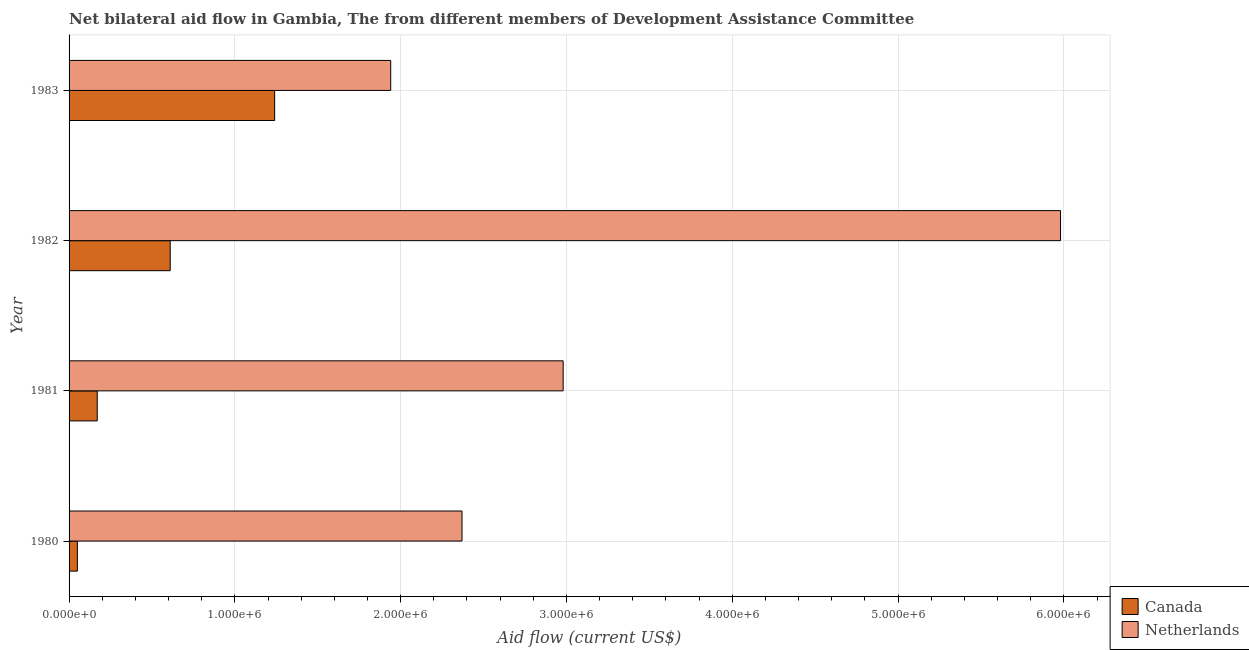How many groups of bars are there?
Your answer should be very brief. 4. Are the number of bars per tick equal to the number of legend labels?
Your answer should be very brief. Yes. Are the number of bars on each tick of the Y-axis equal?
Offer a terse response. Yes. How many bars are there on the 3rd tick from the bottom?
Offer a very short reply. 2. In how many cases, is the number of bars for a given year not equal to the number of legend labels?
Your response must be concise. 0. What is the amount of aid given by canada in 1981?
Your response must be concise. 1.70e+05. Across all years, what is the maximum amount of aid given by netherlands?
Provide a succinct answer. 5.98e+06. Across all years, what is the minimum amount of aid given by netherlands?
Give a very brief answer. 1.94e+06. In which year was the amount of aid given by netherlands maximum?
Your response must be concise. 1982. What is the total amount of aid given by netherlands in the graph?
Offer a terse response. 1.33e+07. What is the difference between the amount of aid given by netherlands in 1981 and that in 1982?
Provide a succinct answer. -3.00e+06. What is the difference between the amount of aid given by canada in 1983 and the amount of aid given by netherlands in 1980?
Provide a succinct answer. -1.13e+06. What is the average amount of aid given by netherlands per year?
Keep it short and to the point. 3.32e+06. In the year 1983, what is the difference between the amount of aid given by netherlands and amount of aid given by canada?
Make the answer very short. 7.00e+05. What is the ratio of the amount of aid given by netherlands in 1980 to that in 1983?
Offer a very short reply. 1.22. Is the amount of aid given by netherlands in 1980 less than that in 1982?
Your answer should be very brief. Yes. Is the difference between the amount of aid given by canada in 1982 and 1983 greater than the difference between the amount of aid given by netherlands in 1982 and 1983?
Make the answer very short. No. What is the difference between the highest and the second highest amount of aid given by netherlands?
Your answer should be compact. 3.00e+06. What is the difference between the highest and the lowest amount of aid given by netherlands?
Your answer should be very brief. 4.04e+06. How many years are there in the graph?
Make the answer very short. 4. What is the difference between two consecutive major ticks on the X-axis?
Ensure brevity in your answer.  1.00e+06. How many legend labels are there?
Offer a very short reply. 2. How are the legend labels stacked?
Provide a short and direct response. Vertical. What is the title of the graph?
Provide a short and direct response. Net bilateral aid flow in Gambia, The from different members of Development Assistance Committee. Does "State government" appear as one of the legend labels in the graph?
Give a very brief answer. No. What is the label or title of the X-axis?
Your response must be concise. Aid flow (current US$). What is the Aid flow (current US$) of Netherlands in 1980?
Your response must be concise. 2.37e+06. What is the Aid flow (current US$) in Netherlands in 1981?
Your answer should be very brief. 2.98e+06. What is the Aid flow (current US$) of Canada in 1982?
Offer a very short reply. 6.10e+05. What is the Aid flow (current US$) in Netherlands in 1982?
Your answer should be very brief. 5.98e+06. What is the Aid flow (current US$) of Canada in 1983?
Offer a terse response. 1.24e+06. What is the Aid flow (current US$) in Netherlands in 1983?
Your answer should be compact. 1.94e+06. Across all years, what is the maximum Aid flow (current US$) of Canada?
Provide a short and direct response. 1.24e+06. Across all years, what is the maximum Aid flow (current US$) in Netherlands?
Give a very brief answer. 5.98e+06. Across all years, what is the minimum Aid flow (current US$) in Canada?
Keep it short and to the point. 5.00e+04. Across all years, what is the minimum Aid flow (current US$) in Netherlands?
Offer a terse response. 1.94e+06. What is the total Aid flow (current US$) of Canada in the graph?
Offer a very short reply. 2.07e+06. What is the total Aid flow (current US$) of Netherlands in the graph?
Ensure brevity in your answer.  1.33e+07. What is the difference between the Aid flow (current US$) in Netherlands in 1980 and that in 1981?
Provide a short and direct response. -6.10e+05. What is the difference between the Aid flow (current US$) in Canada in 1980 and that in 1982?
Give a very brief answer. -5.60e+05. What is the difference between the Aid flow (current US$) of Netherlands in 1980 and that in 1982?
Offer a terse response. -3.61e+06. What is the difference between the Aid flow (current US$) of Canada in 1980 and that in 1983?
Give a very brief answer. -1.19e+06. What is the difference between the Aid flow (current US$) of Netherlands in 1980 and that in 1983?
Offer a terse response. 4.30e+05. What is the difference between the Aid flow (current US$) in Canada in 1981 and that in 1982?
Your answer should be compact. -4.40e+05. What is the difference between the Aid flow (current US$) in Canada in 1981 and that in 1983?
Provide a succinct answer. -1.07e+06. What is the difference between the Aid flow (current US$) in Netherlands in 1981 and that in 1983?
Ensure brevity in your answer.  1.04e+06. What is the difference between the Aid flow (current US$) in Canada in 1982 and that in 1983?
Your answer should be compact. -6.30e+05. What is the difference between the Aid flow (current US$) in Netherlands in 1982 and that in 1983?
Offer a very short reply. 4.04e+06. What is the difference between the Aid flow (current US$) of Canada in 1980 and the Aid flow (current US$) of Netherlands in 1981?
Ensure brevity in your answer.  -2.93e+06. What is the difference between the Aid flow (current US$) of Canada in 1980 and the Aid flow (current US$) of Netherlands in 1982?
Provide a succinct answer. -5.93e+06. What is the difference between the Aid flow (current US$) in Canada in 1980 and the Aid flow (current US$) in Netherlands in 1983?
Provide a succinct answer. -1.89e+06. What is the difference between the Aid flow (current US$) in Canada in 1981 and the Aid flow (current US$) in Netherlands in 1982?
Your answer should be very brief. -5.81e+06. What is the difference between the Aid flow (current US$) of Canada in 1981 and the Aid flow (current US$) of Netherlands in 1983?
Ensure brevity in your answer.  -1.77e+06. What is the difference between the Aid flow (current US$) in Canada in 1982 and the Aid flow (current US$) in Netherlands in 1983?
Make the answer very short. -1.33e+06. What is the average Aid flow (current US$) of Canada per year?
Your answer should be very brief. 5.18e+05. What is the average Aid flow (current US$) of Netherlands per year?
Keep it short and to the point. 3.32e+06. In the year 1980, what is the difference between the Aid flow (current US$) of Canada and Aid flow (current US$) of Netherlands?
Give a very brief answer. -2.32e+06. In the year 1981, what is the difference between the Aid flow (current US$) in Canada and Aid flow (current US$) in Netherlands?
Your answer should be very brief. -2.81e+06. In the year 1982, what is the difference between the Aid flow (current US$) of Canada and Aid flow (current US$) of Netherlands?
Your answer should be very brief. -5.37e+06. In the year 1983, what is the difference between the Aid flow (current US$) of Canada and Aid flow (current US$) of Netherlands?
Make the answer very short. -7.00e+05. What is the ratio of the Aid flow (current US$) in Canada in 1980 to that in 1981?
Ensure brevity in your answer.  0.29. What is the ratio of the Aid flow (current US$) in Netherlands in 1980 to that in 1981?
Provide a short and direct response. 0.8. What is the ratio of the Aid flow (current US$) in Canada in 1980 to that in 1982?
Ensure brevity in your answer.  0.08. What is the ratio of the Aid flow (current US$) of Netherlands in 1980 to that in 1982?
Offer a terse response. 0.4. What is the ratio of the Aid flow (current US$) of Canada in 1980 to that in 1983?
Offer a terse response. 0.04. What is the ratio of the Aid flow (current US$) of Netherlands in 1980 to that in 1983?
Your answer should be very brief. 1.22. What is the ratio of the Aid flow (current US$) of Canada in 1981 to that in 1982?
Your response must be concise. 0.28. What is the ratio of the Aid flow (current US$) in Netherlands in 1981 to that in 1982?
Your response must be concise. 0.5. What is the ratio of the Aid flow (current US$) in Canada in 1981 to that in 1983?
Offer a very short reply. 0.14. What is the ratio of the Aid flow (current US$) in Netherlands in 1981 to that in 1983?
Provide a succinct answer. 1.54. What is the ratio of the Aid flow (current US$) in Canada in 1982 to that in 1983?
Your response must be concise. 0.49. What is the ratio of the Aid flow (current US$) of Netherlands in 1982 to that in 1983?
Provide a succinct answer. 3.08. What is the difference between the highest and the second highest Aid flow (current US$) in Canada?
Give a very brief answer. 6.30e+05. What is the difference between the highest and the second highest Aid flow (current US$) in Netherlands?
Your answer should be compact. 3.00e+06. What is the difference between the highest and the lowest Aid flow (current US$) of Canada?
Give a very brief answer. 1.19e+06. What is the difference between the highest and the lowest Aid flow (current US$) in Netherlands?
Provide a short and direct response. 4.04e+06. 